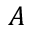<formula> <loc_0><loc_0><loc_500><loc_500>A</formula> 